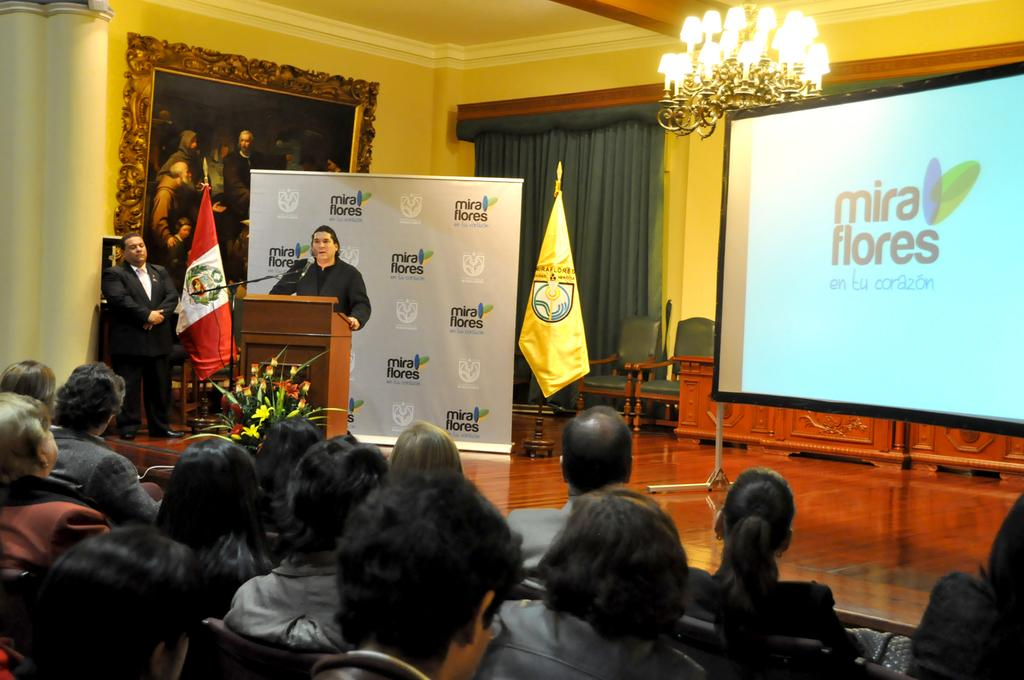What are the people in the image doing? The people in the image are sitting in chairs. What is the person in front doing? The person in front is standing and talking in front of a microphone. What can be seen on the wall in the image? There are borders and frames on the wall in the image. What is visible on the screen in the image? Unfortunately, we cannot determine what is visible on the screen from the provided facts. What type of plastic material is being used for the chairs in the image? There is no information about the material of the chairs in the image. What kind of humor can be observed in the image? There is no humor present in the image; it features people sitting in chairs and a person talking in front of a microphone. 